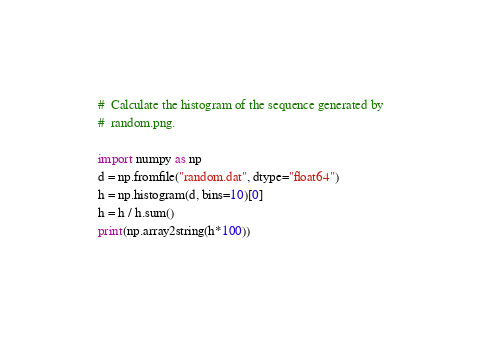<code> <loc_0><loc_0><loc_500><loc_500><_Python_>#  Calculate the histogram of the sequence generated by
#  random.png.

import numpy as np
d = np.fromfile("random.dat", dtype="float64")
h = np.histogram(d, bins=10)[0]
h = h / h.sum()
print(np.array2string(h*100))

</code> 